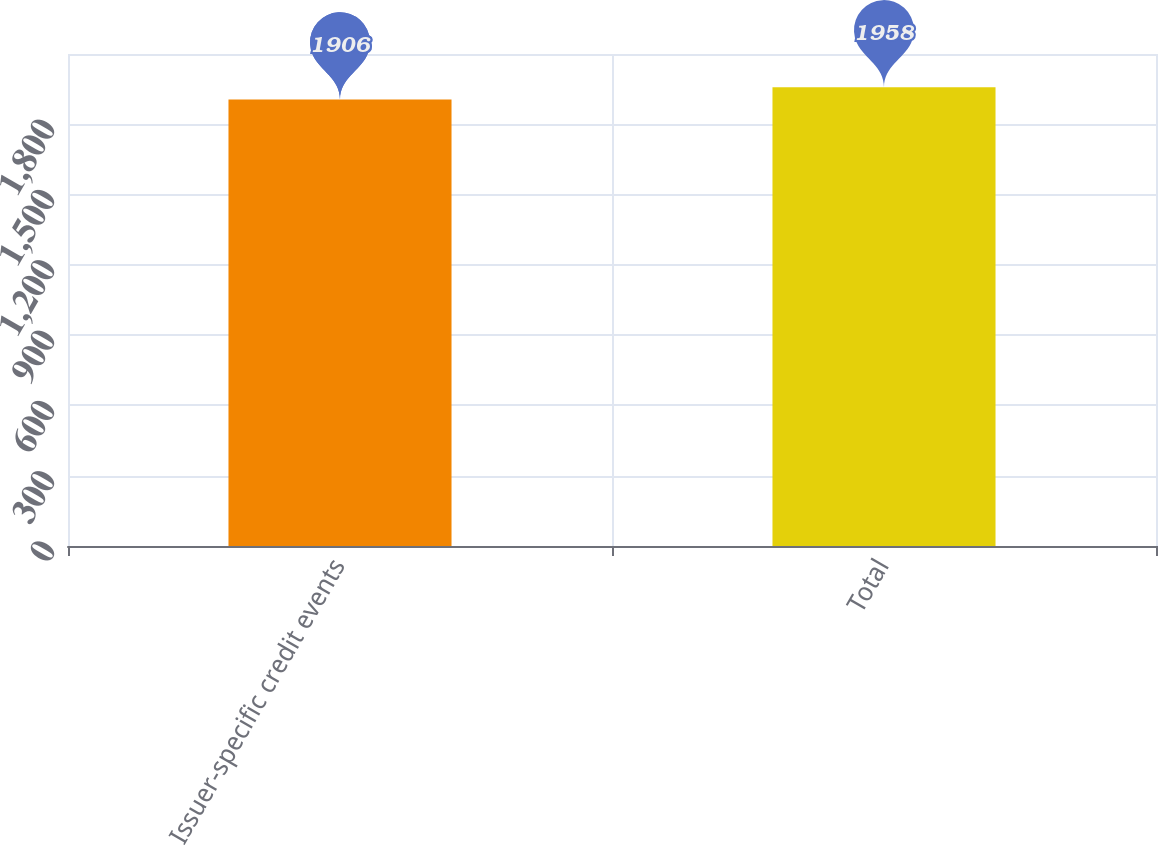<chart> <loc_0><loc_0><loc_500><loc_500><bar_chart><fcel>Issuer-specific credit events<fcel>Total<nl><fcel>1906<fcel>1958<nl></chart> 